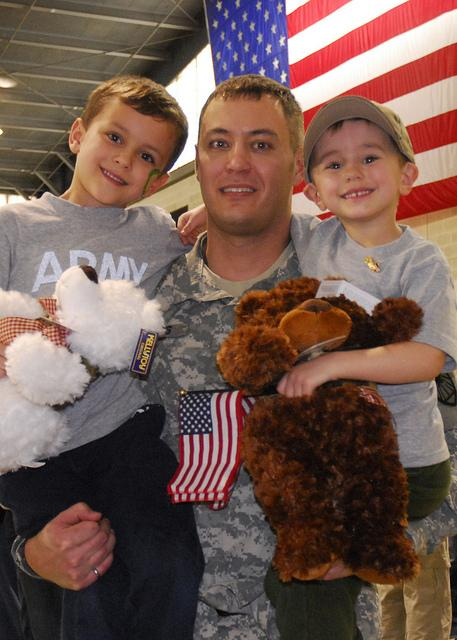What is the man's job?

Choices:
A) soldier
B) waiter
C) electrician
D) dancer soldier 